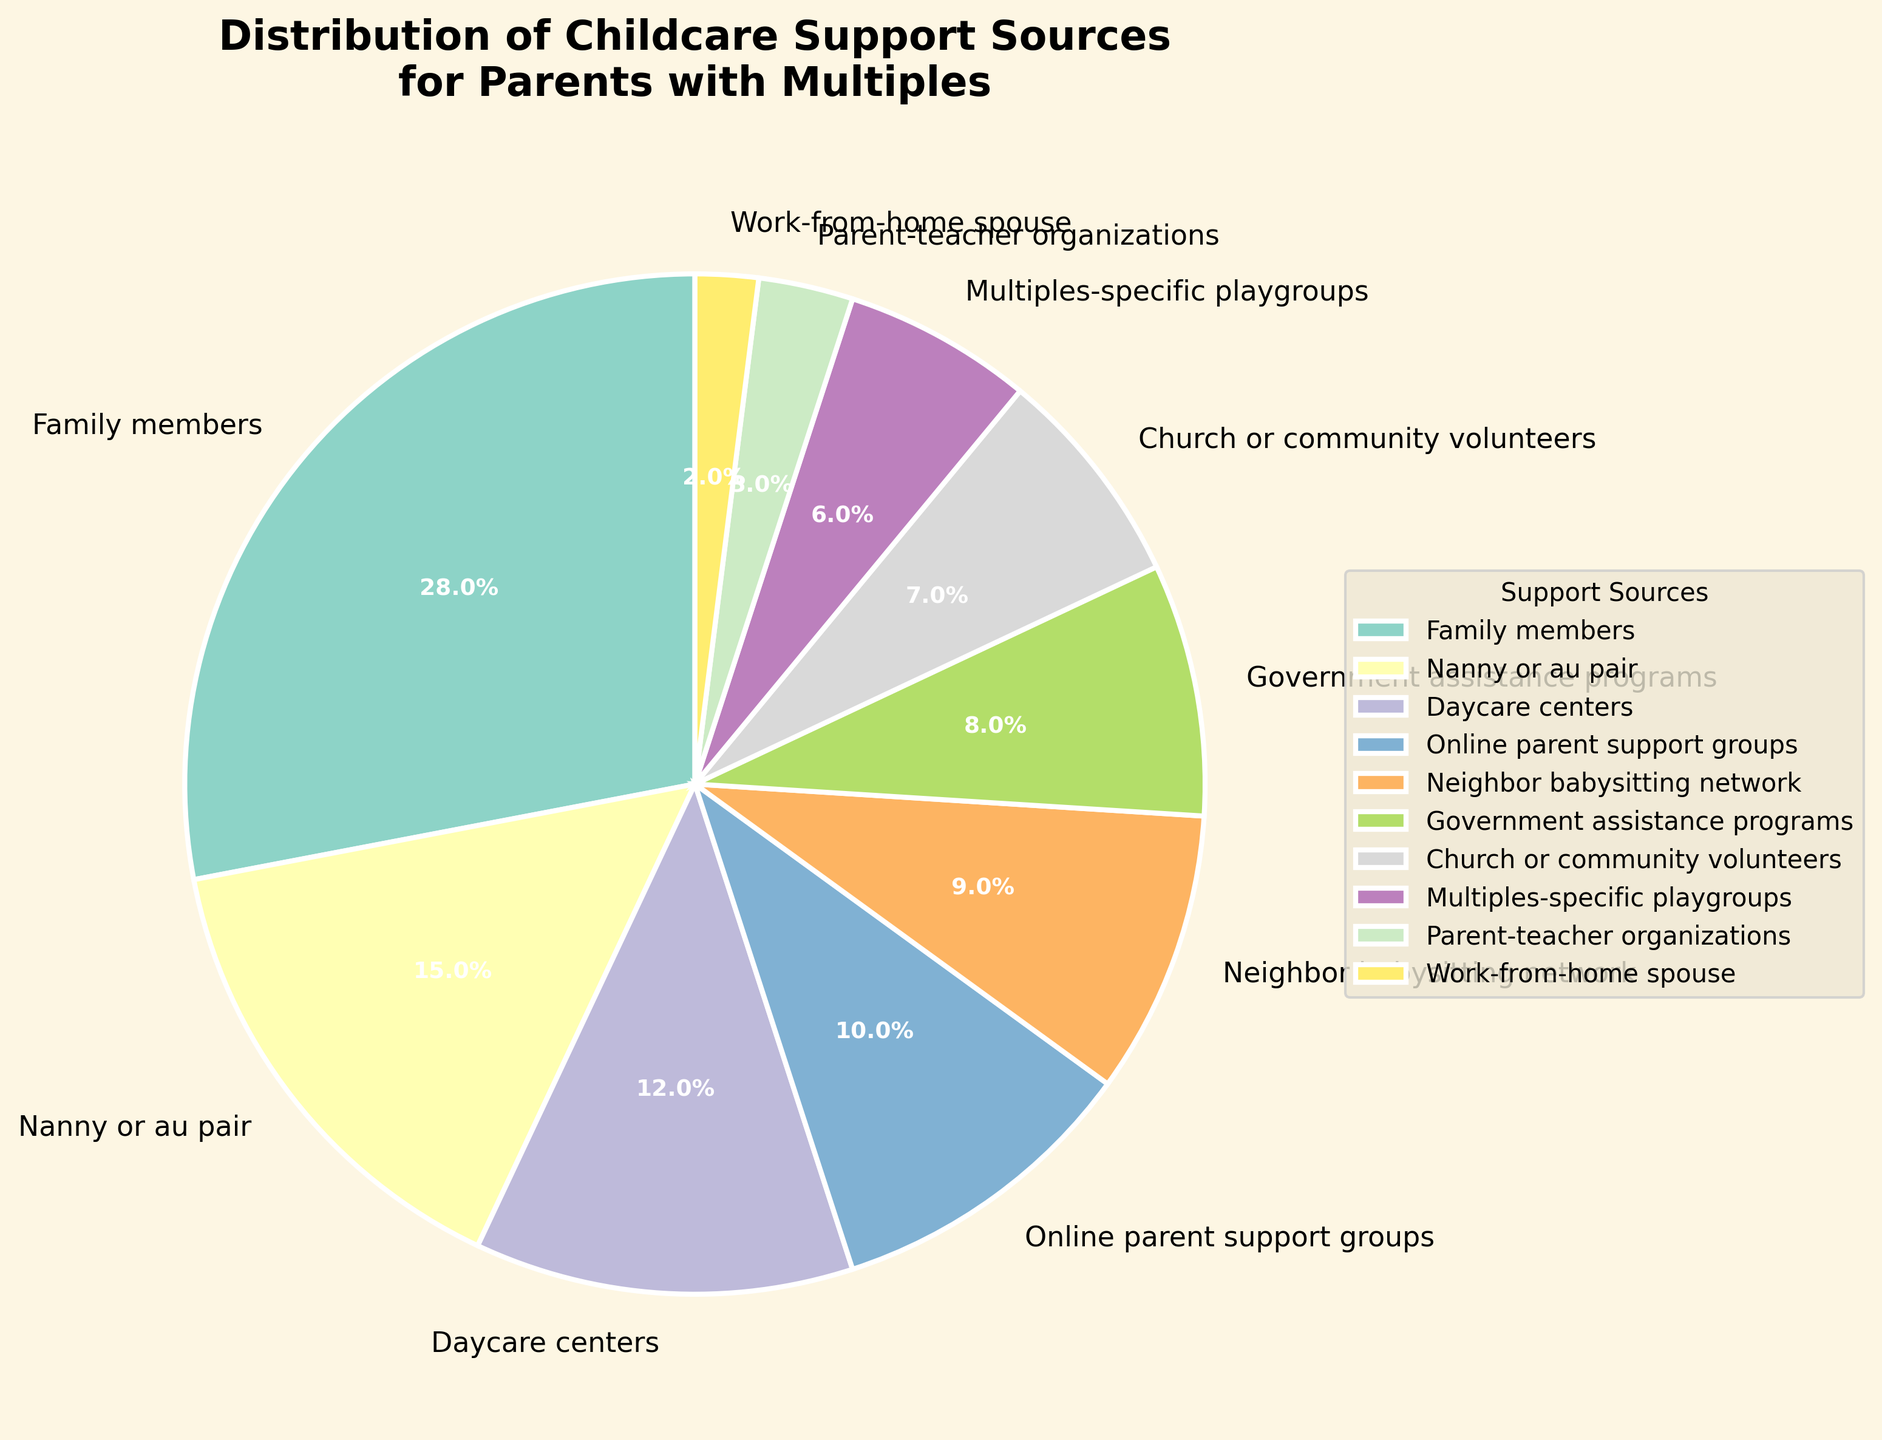How many sources have a support percentage greater than 10%? To find this, look at the pie chart and list the sources with percentages greater than 10. They are: "Family members" (28%), "Nanny or au pair" (15%), and "Daycare centers" (12%). Count these sources.
Answer: 3 What is the combined percentage of support provided by "Family members" and "Nanny or au pair"? The percentage for "Family members" is 28% and for "Nanny or au pair" is 15%. Add these two percentages together: 28 + 15 = 43.
Answer: 43% Which source provides the least percentage of childcare support? Look at the pie chart and identify the section with the smallest percentage. "Work-from-home spouse" provides 2%, which is the smallest.
Answer: Work-from-home spouse Are there more sources with a percentage of support less than or equal to 10% or more than 10%? Count the sources in each category. Less than or equal to 10% are: "Online parent support groups," "Neighbor babysitting network," "Government assistance programs," "Church or community volunteers," "Multiples-specific playgroups," "Parent-teacher organizations," and "Work-from-home spouse" (7 sources). More than 10% are: "Family members," "Nanny or au pair," and "Daycare centers" (3 sources). Compare the counts.
Answer: Less than or equal to 10% What is the difference in percentage between "Church or community volunteers" and "Neighbor babysitting network"? The percentage for "Church or community volunteers" is 7%, and for "Neighbor babysitting network" is 9%. Subtract the smaller percentage from the larger one: 9 - 7 = 2.
Answer: 2% What percentage of support is provided by sources that are neither family members, nannies, nor daycare centers combined? Exclude "Family members" (28%), "Nanny or au pair" (15%), and "Daycare centers" (12%). Sum all other percentages: 10 + 9 + 8 + 7 + 6 + 3 + 2 = 45.
Answer: 45% Which color represents the source providing an 8% support in the pie chart? Visual question: Look at the color representing the 8% slice in the pie chart. This color corresponds to "Government assistance programs."
Answer: The color corresponding to Government assistance programs What two sources together provide equal support as that provided by "Family members"? The percentage for "Family members" is 28%. Look for two sources whose combined percentages equal 28. "Nanny or au pair" (15%) and "Government assistance programs" (8%) do not equal to 28. However, "Online parent support groups" (10%) and "Neighbor babysitting network" (9%) and any other source. Specifically "Online parent support groups" (10%) and "Multiples-specific playgroups" (6%) together is equal to "Daycare centers" (12%) and "Nanny or au pair" (15%)
Answer: Nanny or au pair and Daycare centers 